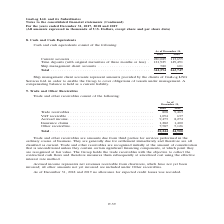From Gaslog's financial document, In which years was the cash and cash equivalents recorded for? The document shows two values: 2018 and 2019. From the document: ") For the years ended December 31, 2017, 2018 and 2019 (All amounts expressed in thousands of U.S. Dollars, except share and per share data) Continued..." Also, What does ship management client accounts represent? Ship management client accounts represent amounts provided by the clients of GasLog LNG Services Ltd. in order to enable the Group to cover obligations of vessels under management.. The document states: "Ship management client accounts represent amounts provided by the clients of GasLog LNG Services Ltd. in order to enable the Group to cover obligation..." Also, What was the amount of ship management client accounts in 2018? According to the financial document, 580 (in thousands). The relevant text states: "121,925 149,491 Ship management client accounts . 580 601..." Additionally, In which year was the time deposits higher? According to the financial document, 2019. The relevant text states: ") For the years ended December 31, 2017, 2018 and 2019 (All amounts expressed in thousands of U.S. Dollars, except share and per share data)..." Also, can you calculate: What was the change in current accounts  from 2018 to 2019? Based on the calculation: 113,655 - 220,089 , the result is -106434 (in thousands). This is based on the information: "Current accounts . 220,089 113,655 Time deposits (with original maturities of three months or less) . 121,925 149,491 Ship man Current accounts . 220,089 113,655 Time deposits (with original maturitie..." The key data points involved are: 113,655, 220,089. Also, can you calculate: What was the percentage change in total cash and cash equivalents from 2018 to 2019? To answer this question, I need to perform calculations using the financial data. The calculation is: (263,747 - 342,594)/342,594 , which equals -23.01 (percentage). This is based on the information: "Total . 342,594 263,747 Total . 342,594 263,747..." The key data points involved are: 263,747, 342,594. 